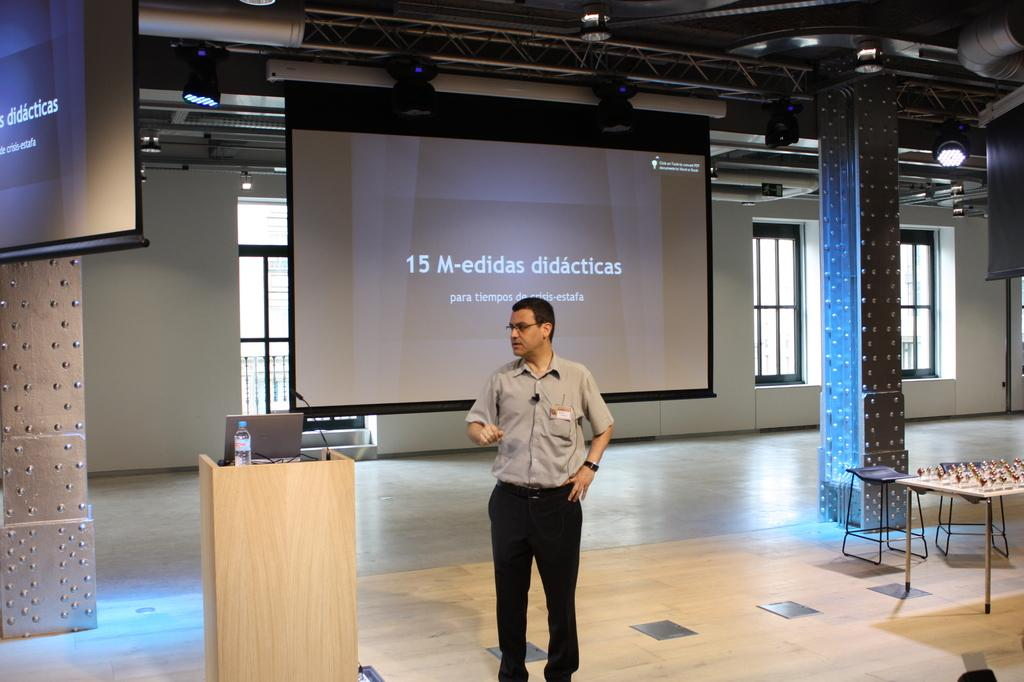Provide a one-sentence caption for the provided image. a man with a presentation behind him with the number 15 on it. 